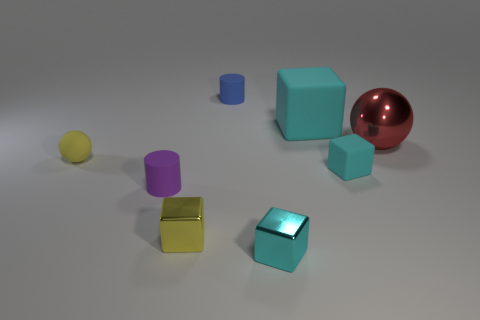Subtract all purple cylinders. How many cyan cubes are left? 3 Subtract all green blocks. Subtract all yellow cylinders. How many blocks are left? 4 Add 1 tiny red rubber cylinders. How many objects exist? 9 Subtract all cylinders. How many objects are left? 6 Subtract 0 gray cubes. How many objects are left? 8 Subtract all blue things. Subtract all small yellow rubber spheres. How many objects are left? 6 Add 2 tiny cyan blocks. How many tiny cyan blocks are left? 4 Add 5 large purple cylinders. How many large purple cylinders exist? 5 